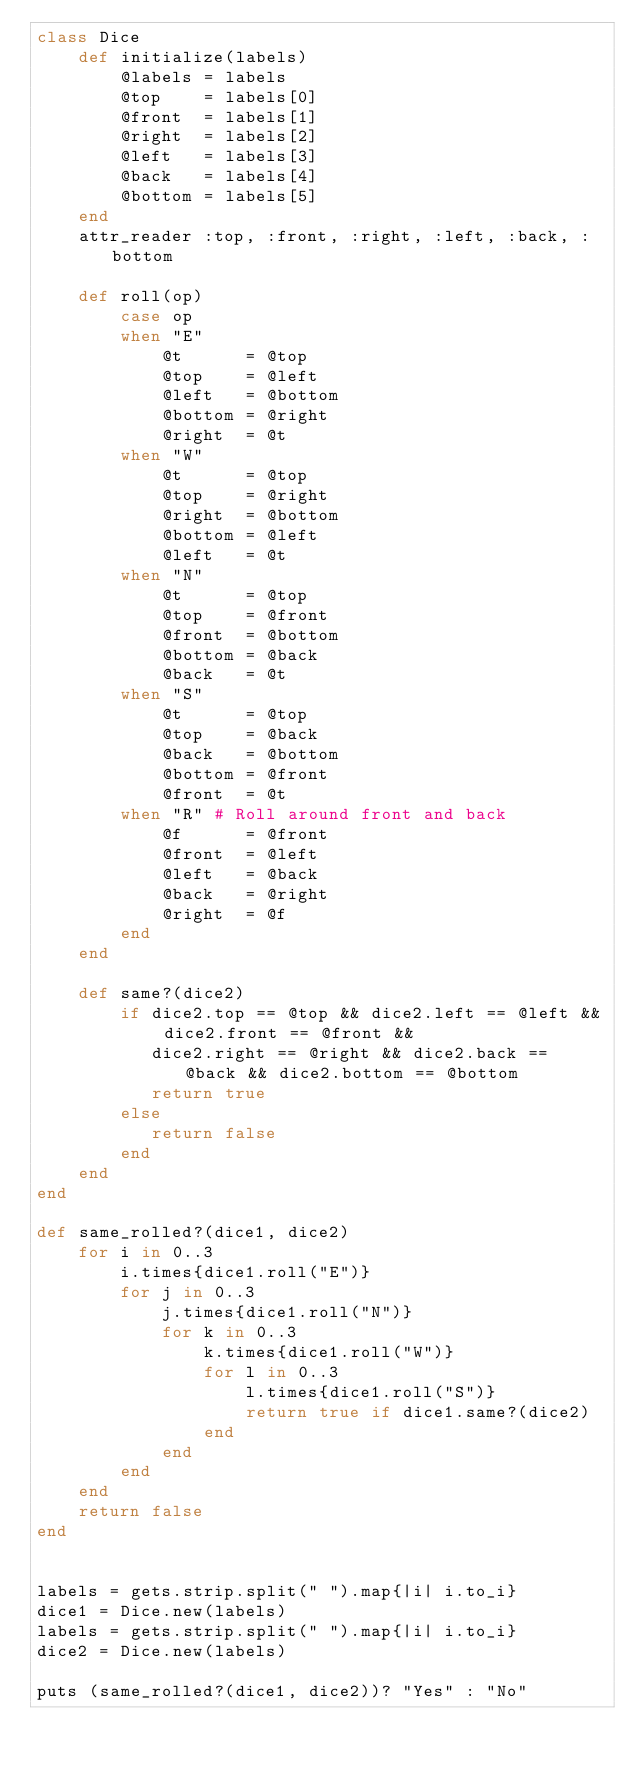<code> <loc_0><loc_0><loc_500><loc_500><_Ruby_>class Dice
	def initialize(labels)
		@labels = labels
		@top    = labels[0]
		@front  = labels[1]
		@right  = labels[2]
		@left   = labels[3]
		@back   = labels[4]
		@bottom = labels[5]
	end
	attr_reader :top, :front, :right, :left, :back, :bottom

	def roll(op)
		case op
		when "E"
			@t      = @top
			@top    = @left
			@left   = @bottom
			@bottom = @right
			@right  = @t
		when "W"
			@t      = @top
			@top    = @right
			@right  = @bottom
			@bottom = @left
			@left   = @t
		when "N"
			@t      = @top
			@top    = @front
			@front  = @bottom
			@bottom = @back
			@back   = @t
		when "S"
			@t      = @top
			@top    = @back
			@back   = @bottom
			@bottom = @front
			@front  = @t
		when "R" # Roll around front and back
			@f      = @front
			@front  = @left
			@left   = @back
			@back   = @right
			@right  = @f 
		end
	end

	def same?(dice2)
		if dice2.top == @top && dice2.left == @left && dice2.front == @front &&
		   dice2.right == @right && dice2.back == @back && dice2.bottom == @bottom 
		   return true
		else
		   return false
		end
	end
end

def same_rolled?(dice1, dice2)
	for i in 0..3
		i.times{dice1.roll("E")}
		for j in 0..3
			j.times{dice1.roll("N")}
			for k in 0..3
				k.times{dice1.roll("W")}
				for l in 0..3
					l.times{dice1.roll("S")}
					return true if dice1.same?(dice2)
				end
			end
		end
	end
	return false
end


labels = gets.strip.split(" ").map{|i| i.to_i}
dice1 = Dice.new(labels)
labels = gets.strip.split(" ").map{|i| i.to_i}
dice2 = Dice.new(labels)

puts (same_rolled?(dice1, dice2))? "Yes" : "No"
</code> 